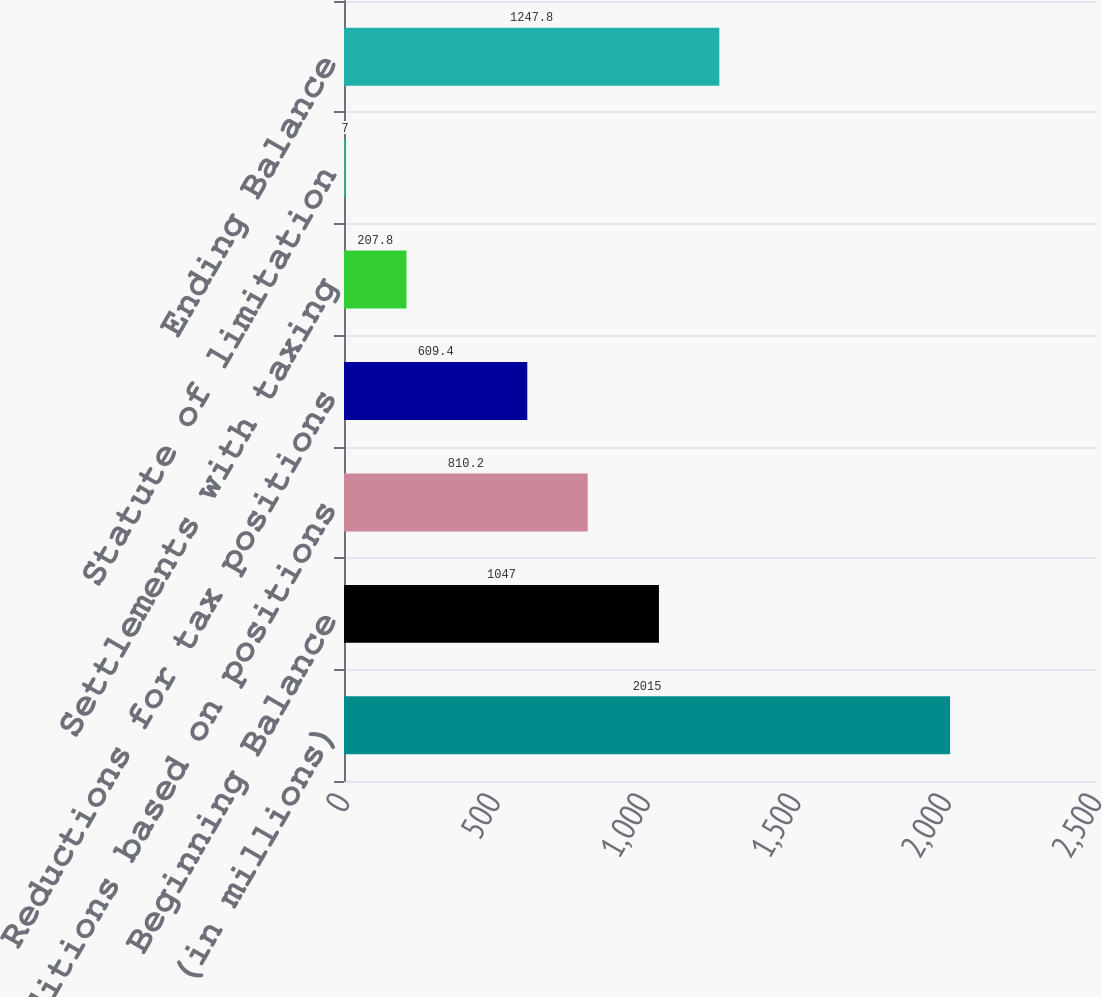<chart> <loc_0><loc_0><loc_500><loc_500><bar_chart><fcel>(in millions)<fcel>Beginning Balance<fcel>Additions based on positions<fcel>Reductions for tax positions<fcel>Settlements with taxing<fcel>Statute of limitation<fcel>Ending Balance<nl><fcel>2015<fcel>1047<fcel>810.2<fcel>609.4<fcel>207.8<fcel>7<fcel>1247.8<nl></chart> 